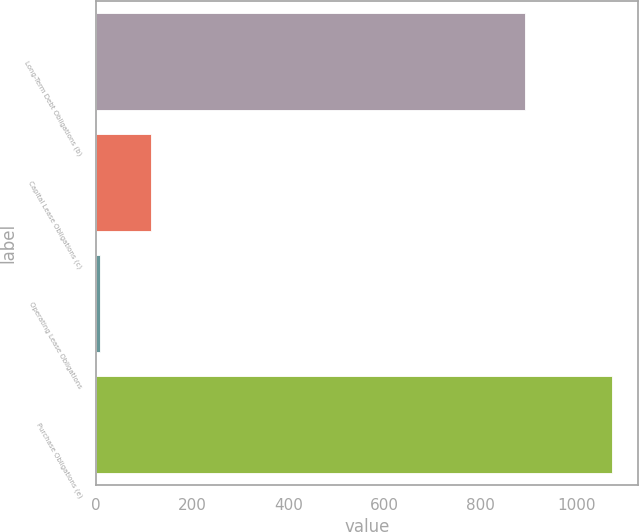Convert chart. <chart><loc_0><loc_0><loc_500><loc_500><bar_chart><fcel>Long-Term Debt Obligations (b)<fcel>Capital Lease Obligations (c)<fcel>Operating Lease Obligations<fcel>Purchase Obligations (e)<nl><fcel>891.1<fcel>114.08<fcel>7.6<fcel>1072.4<nl></chart> 